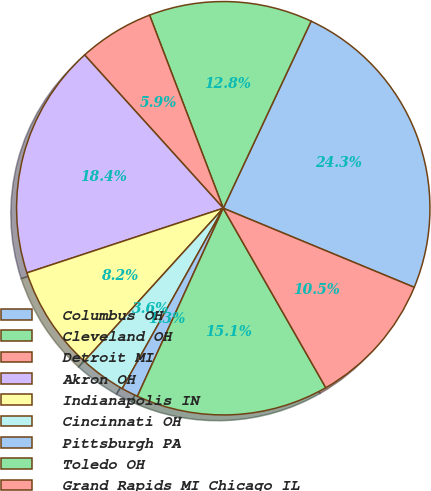<chart> <loc_0><loc_0><loc_500><loc_500><pie_chart><fcel>Columbus OH<fcel>Cleveland OH<fcel>Detroit MI<fcel>Akron OH<fcel>Indianapolis IN<fcel>Cincinnati OH<fcel>Pittsburgh PA<fcel>Toledo OH<fcel>Grand Rapids MI Chicago IL<nl><fcel>24.26%<fcel>12.79%<fcel>5.9%<fcel>18.36%<fcel>8.2%<fcel>3.61%<fcel>1.31%<fcel>15.08%<fcel>10.49%<nl></chart> 